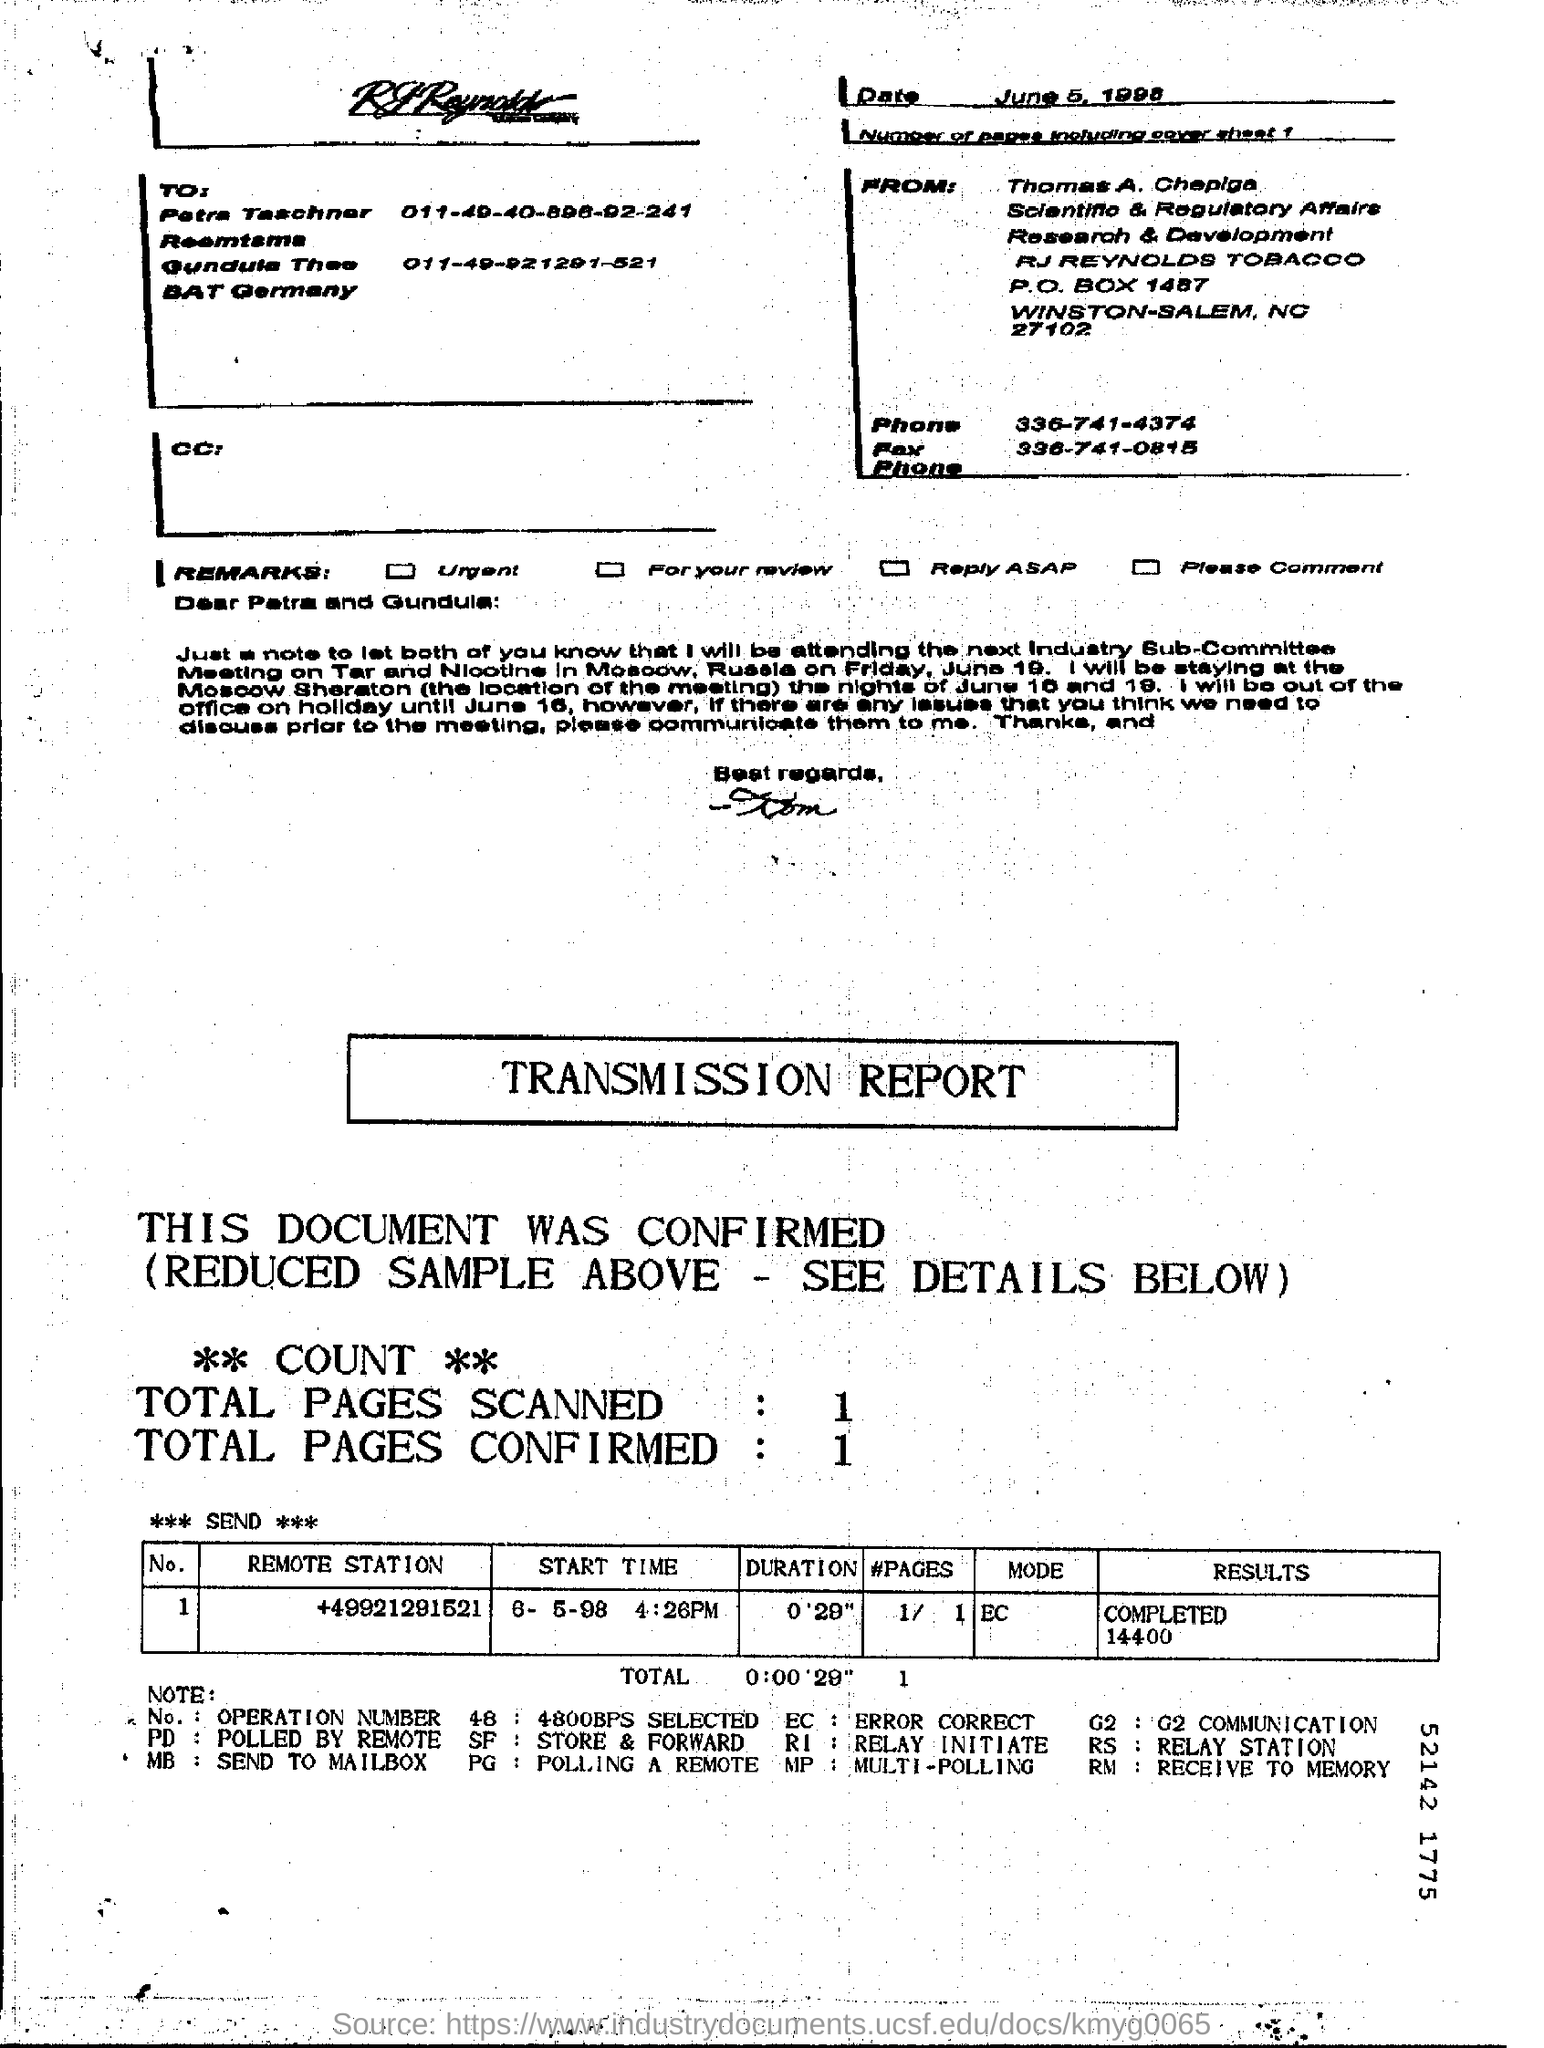What type of document formatting is used in this transmission report? This document uses a structured format typical of a transmission report, including sections for the total number of pages scanned, a header with sender and receiver information, and remarks related to the urgency and need for replies.  Could this document be related to legal or regulatory compliance? Given that the document is from a department handling scientific and regulatory affairs and addresses individuals in Germany, it could very well be related to compliance issues or regulatory matters pertinent to their business operations. 